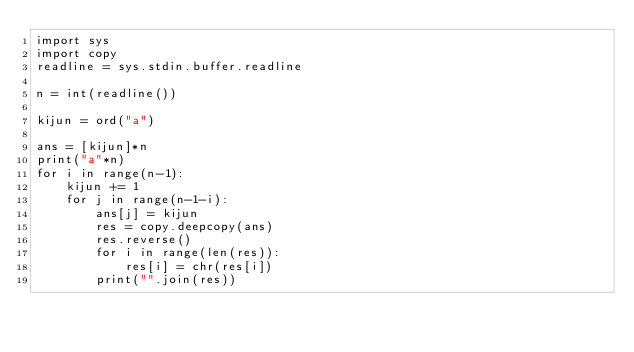Convert code to text. <code><loc_0><loc_0><loc_500><loc_500><_Python_>import sys
import copy
readline = sys.stdin.buffer.readline

n = int(readline())

kijun = ord("a")

ans = [kijun]*n
print("a"*n)
for i in range(n-1):
    kijun += 1
    for j in range(n-1-i):
        ans[j] = kijun
        res = copy.deepcopy(ans)
        res.reverse()
        for i in range(len(res)):
            res[i] = chr(res[i])
        print("".join(res))</code> 